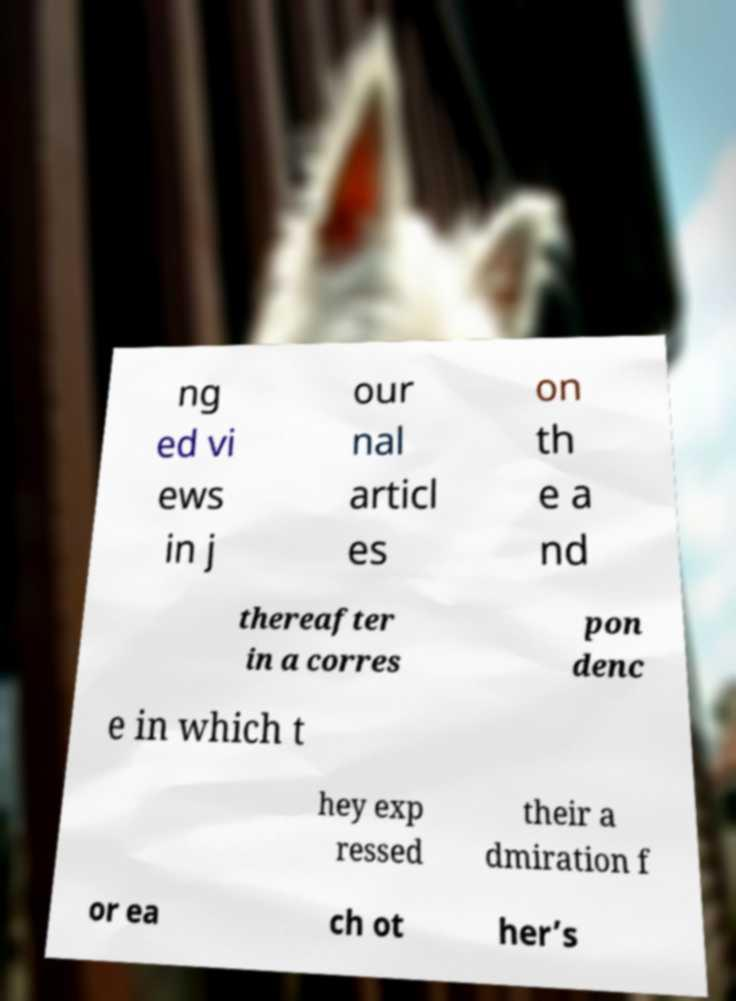There's text embedded in this image that I need extracted. Can you transcribe it verbatim? ng ed vi ews in j our nal articl es on th e a nd thereafter in a corres pon denc e in which t hey exp ressed their a dmiration f or ea ch ot her’s 